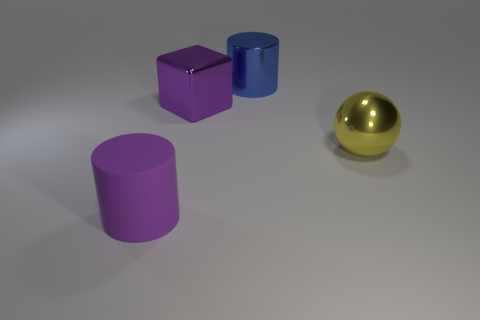Is the number of purple cubes that are in front of the yellow sphere less than the number of purple blocks?
Offer a terse response. Yes. There is a large blue thing that is made of the same material as the big block; what is its shape?
Offer a very short reply. Cylinder. How many shiny objects are either balls or big cylinders?
Your answer should be compact. 2. Is the number of big rubber things that are behind the blue shiny cylinder the same as the number of objects?
Offer a terse response. No. Is the color of the large cylinder that is in front of the cube the same as the shiny cube?
Ensure brevity in your answer.  Yes. There is a object that is both behind the large yellow shiny ball and left of the blue cylinder; what material is it made of?
Make the answer very short. Metal. There is a yellow metal thing that is to the right of the purple metallic block; is there a yellow shiny ball that is left of it?
Your answer should be compact. No. Is the material of the large purple cylinder the same as the large ball?
Provide a succinct answer. No. The metal object that is both on the left side of the sphere and in front of the metal cylinder has what shape?
Provide a short and direct response. Cube. What is the size of the cylinder behind the big metal object left of the big blue object?
Provide a succinct answer. Large. 